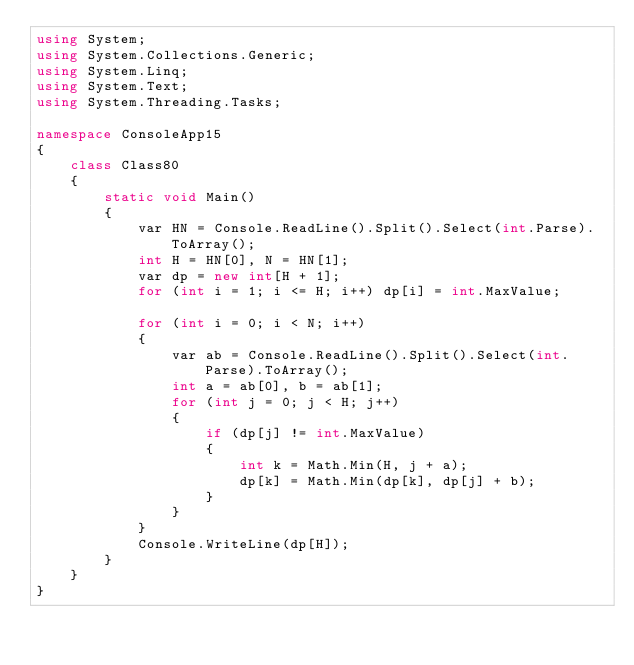Convert code to text. <code><loc_0><loc_0><loc_500><loc_500><_C#_>using System;
using System.Collections.Generic;
using System.Linq;
using System.Text;
using System.Threading.Tasks;

namespace ConsoleApp15
{
    class Class80
    {
        static void Main()
        {
            var HN = Console.ReadLine().Split().Select(int.Parse).ToArray();
            int H = HN[0], N = HN[1];
            var dp = new int[H + 1];
            for (int i = 1; i <= H; i++) dp[i] = int.MaxValue;

            for (int i = 0; i < N; i++)
            {
                var ab = Console.ReadLine().Split().Select(int.Parse).ToArray();
                int a = ab[0], b = ab[1];
                for (int j = 0; j < H; j++)
                {
                    if (dp[j] != int.MaxValue)
                    {
                        int k = Math.Min(H, j + a);
                        dp[k] = Math.Min(dp[k], dp[j] + b);
                    }
                }
            }
            Console.WriteLine(dp[H]);
        }
    }
}
</code> 